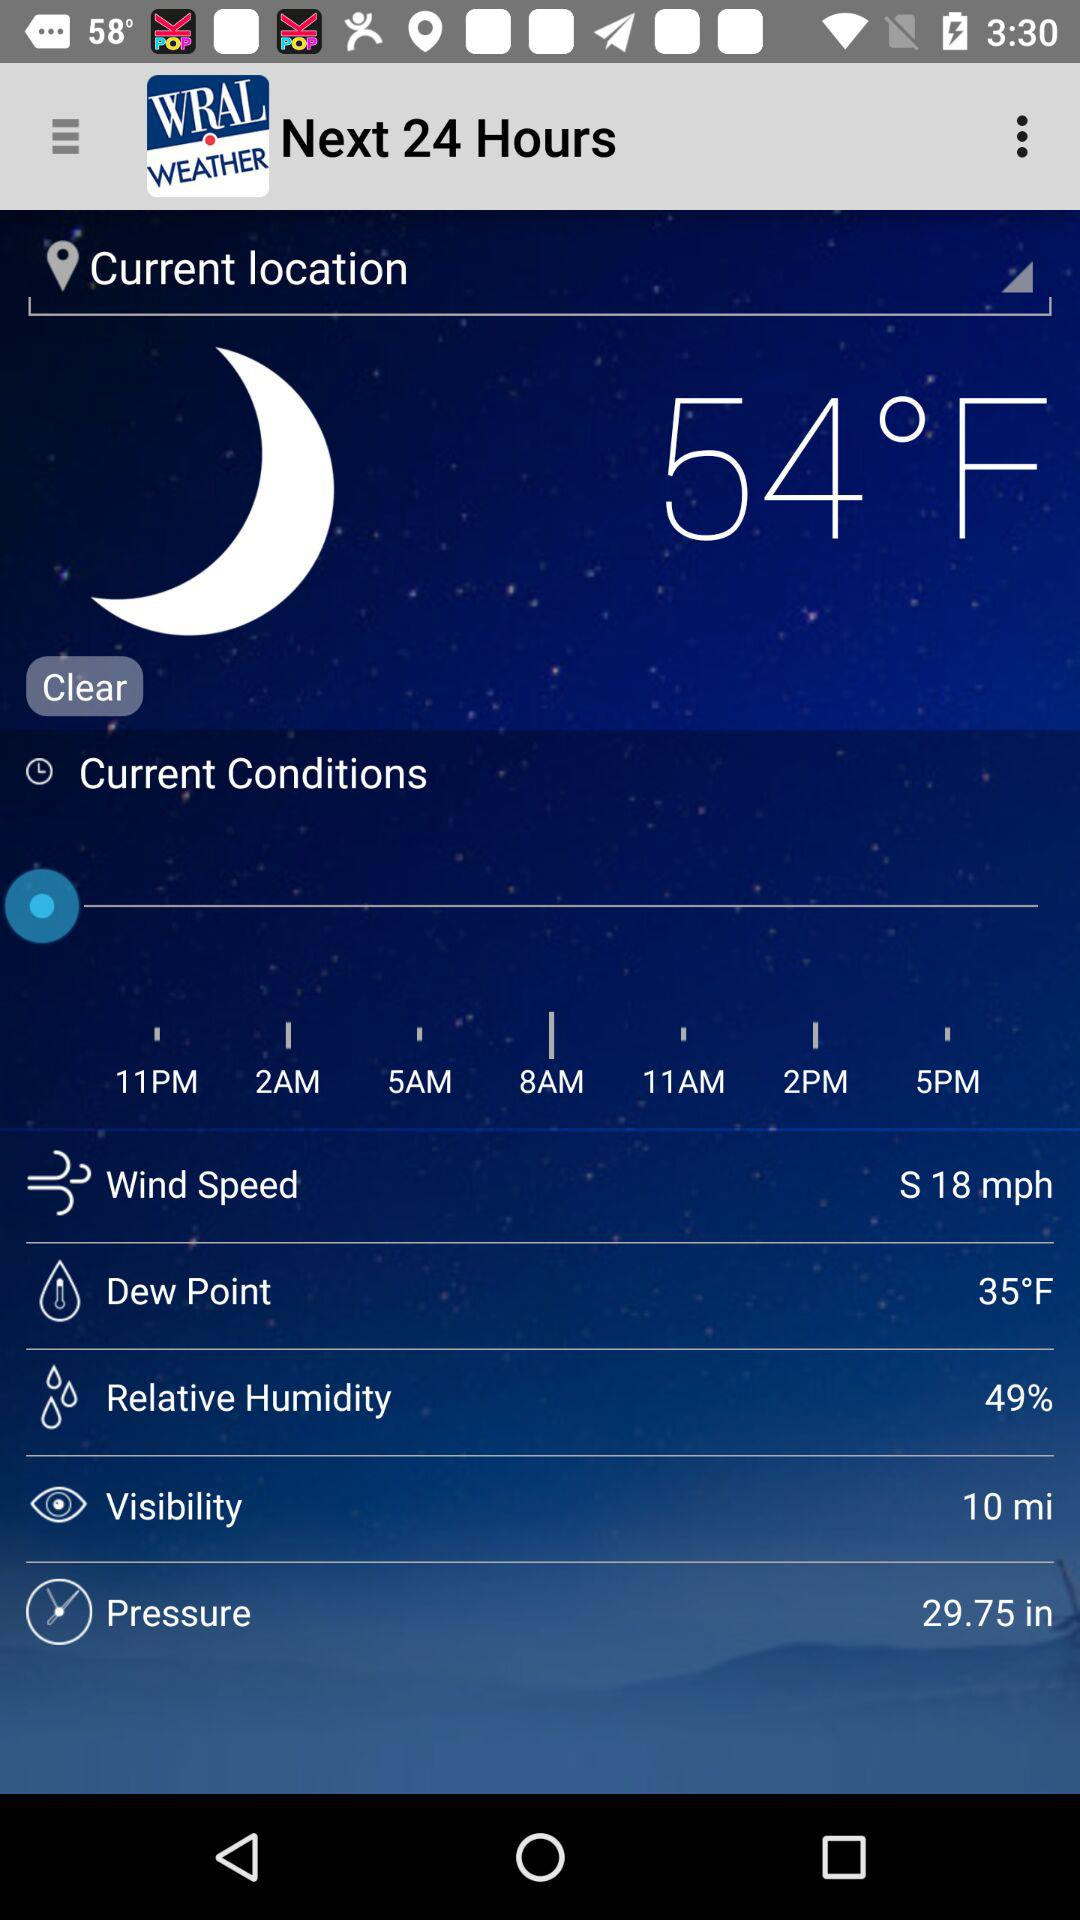How many hours are in the forecast?
Answer the question using a single word or phrase. 24 